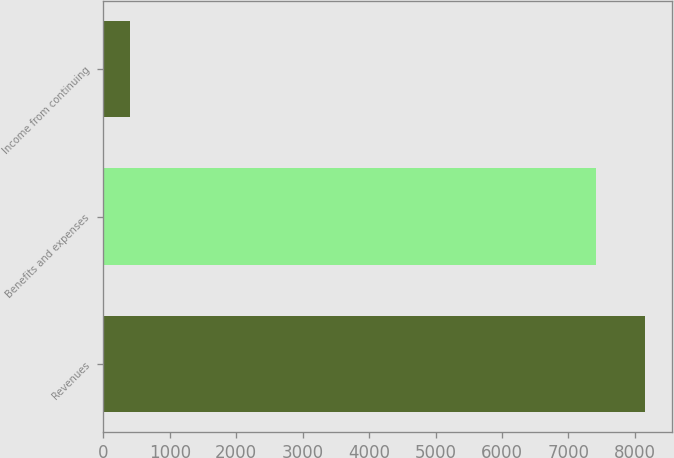Convert chart to OTSL. <chart><loc_0><loc_0><loc_500><loc_500><bar_chart><fcel>Revenues<fcel>Benefits and expenses<fcel>Income from continuing<nl><fcel>8149.9<fcel>7409<fcel>403<nl></chart> 